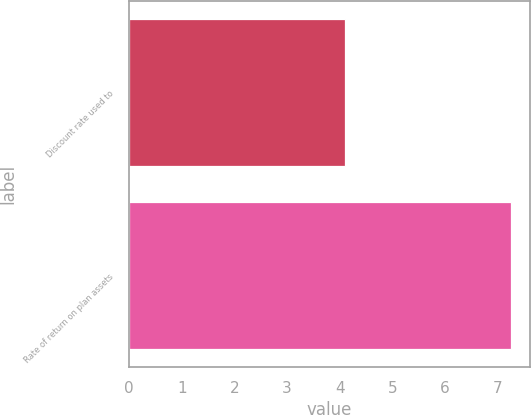<chart> <loc_0><loc_0><loc_500><loc_500><bar_chart><fcel>Discount rate used to<fcel>Rate of return on plan assets<nl><fcel>4.1<fcel>7.25<nl></chart> 